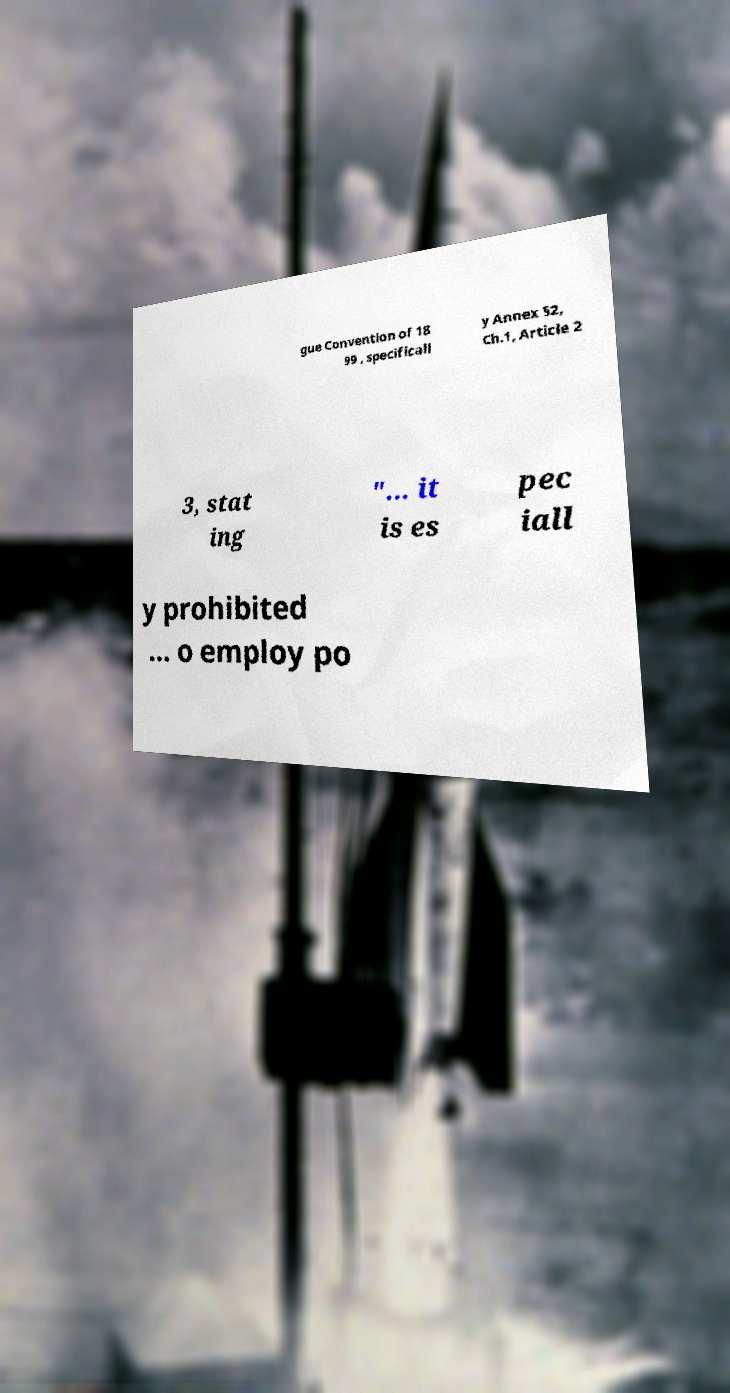Please identify and transcribe the text found in this image. gue Convention of 18 99 , specificall y Annex §2, Ch.1, Article 2 3, stat ing "... it is es pec iall y prohibited ... o employ po 